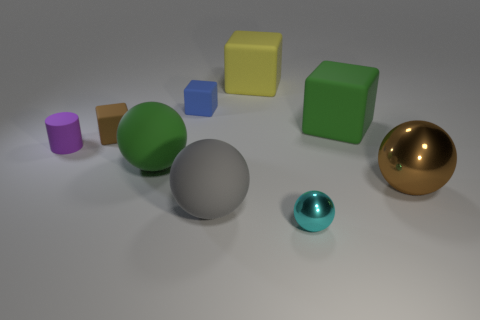There is a brown object in front of the tiny matte block that is in front of the small thing that is behind the large green matte cube; what is its size?
Offer a very short reply. Large. There is a large yellow object; does it have the same shape as the green object to the right of the blue thing?
Provide a short and direct response. Yes. What material is the tiny cylinder?
Keep it short and to the point. Rubber. How many rubber things are either small purple objects or large red cubes?
Offer a terse response. 1. Are there fewer small objects to the right of the large metal thing than tiny blue matte blocks left of the brown cube?
Your response must be concise. No. There is a green object that is on the left side of the gray object that is left of the brown shiny sphere; are there any brown objects right of it?
Offer a terse response. Yes. There is a cube that is the same color as the large metal ball; what is its material?
Your answer should be compact. Rubber. Do the large green rubber object in front of the brown matte block and the green object that is to the right of the cyan metallic sphere have the same shape?
Give a very brief answer. No. What material is the blue object that is the same size as the cyan thing?
Ensure brevity in your answer.  Rubber. Do the big green object behind the purple matte object and the brown object that is left of the large gray matte ball have the same material?
Offer a very short reply. Yes. 